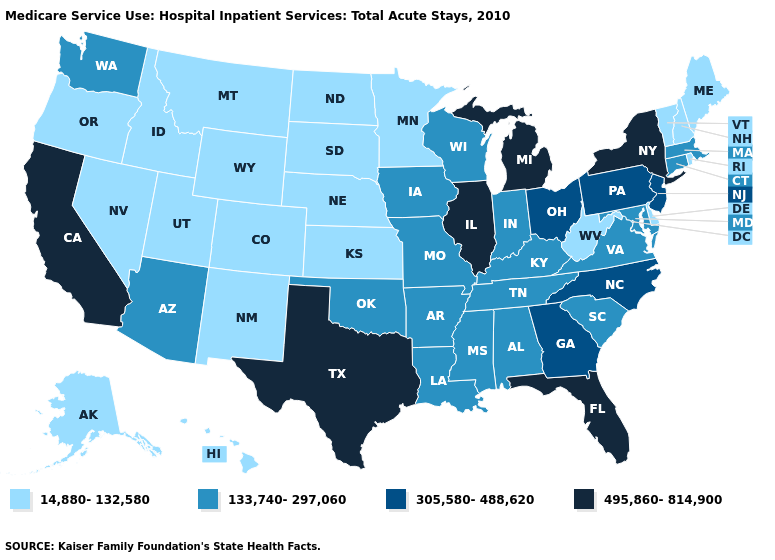Name the states that have a value in the range 495,860-814,900?
Concise answer only. California, Florida, Illinois, Michigan, New York, Texas. Which states hav the highest value in the West?
Give a very brief answer. California. What is the value of North Carolina?
Give a very brief answer. 305,580-488,620. Name the states that have a value in the range 133,740-297,060?
Be succinct. Alabama, Arizona, Arkansas, Connecticut, Indiana, Iowa, Kentucky, Louisiana, Maryland, Massachusetts, Mississippi, Missouri, Oklahoma, South Carolina, Tennessee, Virginia, Washington, Wisconsin. Which states hav the highest value in the Northeast?
Write a very short answer. New York. Among the states that border Wisconsin , does Minnesota have the lowest value?
Be succinct. Yes. What is the value of Virginia?
Be succinct. 133,740-297,060. Does California have the lowest value in the West?
Short answer required. No. What is the value of South Carolina?
Be succinct. 133,740-297,060. Does Delaware have the lowest value in the USA?
Keep it brief. Yes. What is the value of New Jersey?
Give a very brief answer. 305,580-488,620. Which states have the highest value in the USA?
Give a very brief answer. California, Florida, Illinois, Michigan, New York, Texas. Name the states that have a value in the range 305,580-488,620?
Quick response, please. Georgia, New Jersey, North Carolina, Ohio, Pennsylvania. Is the legend a continuous bar?
Keep it brief. No. What is the lowest value in states that border Iowa?
Answer briefly. 14,880-132,580. 